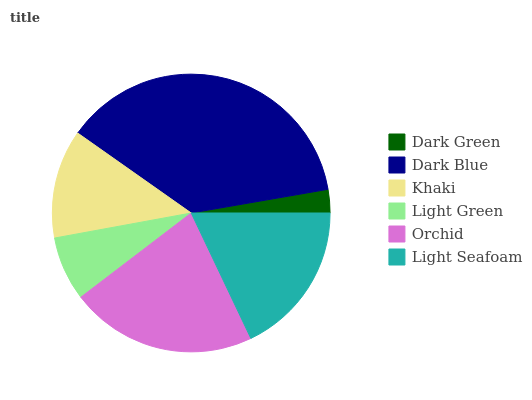Is Dark Green the minimum?
Answer yes or no. Yes. Is Dark Blue the maximum?
Answer yes or no. Yes. Is Khaki the minimum?
Answer yes or no. No. Is Khaki the maximum?
Answer yes or no. No. Is Dark Blue greater than Khaki?
Answer yes or no. Yes. Is Khaki less than Dark Blue?
Answer yes or no. Yes. Is Khaki greater than Dark Blue?
Answer yes or no. No. Is Dark Blue less than Khaki?
Answer yes or no. No. Is Light Seafoam the high median?
Answer yes or no. Yes. Is Khaki the low median?
Answer yes or no. Yes. Is Orchid the high median?
Answer yes or no. No. Is Dark Green the low median?
Answer yes or no. No. 